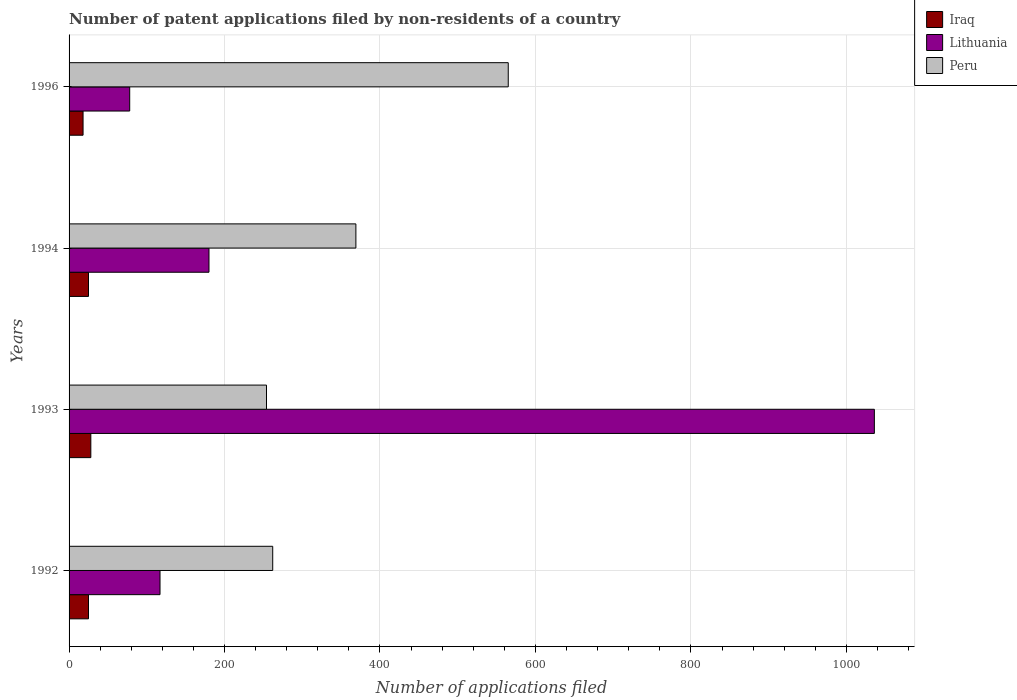How many different coloured bars are there?
Make the answer very short. 3. How many groups of bars are there?
Provide a succinct answer. 4. Are the number of bars per tick equal to the number of legend labels?
Ensure brevity in your answer.  Yes. How many bars are there on the 2nd tick from the bottom?
Your answer should be compact. 3. What is the label of the 4th group of bars from the top?
Ensure brevity in your answer.  1992. In how many cases, is the number of bars for a given year not equal to the number of legend labels?
Offer a terse response. 0. What is the number of applications filed in Lithuania in 1994?
Offer a very short reply. 180. Across all years, what is the maximum number of applications filed in Peru?
Your response must be concise. 565. In which year was the number of applications filed in Iraq maximum?
Give a very brief answer. 1993. What is the total number of applications filed in Peru in the graph?
Make the answer very short. 1450. What is the difference between the number of applications filed in Lithuania in 1993 and that in 1994?
Provide a succinct answer. 856. What is the difference between the number of applications filed in Iraq in 1994 and the number of applications filed in Peru in 1993?
Your answer should be very brief. -229. What is the average number of applications filed in Peru per year?
Keep it short and to the point. 362.5. In the year 1992, what is the difference between the number of applications filed in Peru and number of applications filed in Iraq?
Keep it short and to the point. 237. In how many years, is the number of applications filed in Peru greater than 120 ?
Your answer should be compact. 4. What is the ratio of the number of applications filed in Lithuania in 1993 to that in 1996?
Keep it short and to the point. 13.28. Is the number of applications filed in Peru in 1993 less than that in 1994?
Provide a short and direct response. Yes. Is the difference between the number of applications filed in Peru in 1994 and 1996 greater than the difference between the number of applications filed in Iraq in 1994 and 1996?
Ensure brevity in your answer.  No. What is the difference between the highest and the second highest number of applications filed in Peru?
Keep it short and to the point. 196. What is the difference between the highest and the lowest number of applications filed in Lithuania?
Provide a succinct answer. 958. Is the sum of the number of applications filed in Iraq in 1994 and 1996 greater than the maximum number of applications filed in Lithuania across all years?
Your answer should be compact. No. What does the 1st bar from the bottom in 1996 represents?
Offer a terse response. Iraq. Are all the bars in the graph horizontal?
Keep it short and to the point. Yes. How many years are there in the graph?
Your answer should be compact. 4. Are the values on the major ticks of X-axis written in scientific E-notation?
Offer a very short reply. No. Does the graph contain any zero values?
Keep it short and to the point. No. Does the graph contain grids?
Your answer should be very brief. Yes. Where does the legend appear in the graph?
Offer a very short reply. Top right. How many legend labels are there?
Your response must be concise. 3. How are the legend labels stacked?
Offer a very short reply. Vertical. What is the title of the graph?
Offer a very short reply. Number of patent applications filed by non-residents of a country. Does "Canada" appear as one of the legend labels in the graph?
Give a very brief answer. No. What is the label or title of the X-axis?
Your response must be concise. Number of applications filed. What is the label or title of the Y-axis?
Make the answer very short. Years. What is the Number of applications filed of Iraq in 1992?
Offer a very short reply. 25. What is the Number of applications filed in Lithuania in 1992?
Your answer should be very brief. 117. What is the Number of applications filed in Peru in 1992?
Provide a short and direct response. 262. What is the Number of applications filed of Iraq in 1993?
Offer a very short reply. 28. What is the Number of applications filed in Lithuania in 1993?
Offer a very short reply. 1036. What is the Number of applications filed in Peru in 1993?
Ensure brevity in your answer.  254. What is the Number of applications filed in Iraq in 1994?
Give a very brief answer. 25. What is the Number of applications filed of Lithuania in 1994?
Your answer should be very brief. 180. What is the Number of applications filed in Peru in 1994?
Your answer should be very brief. 369. What is the Number of applications filed in Iraq in 1996?
Offer a very short reply. 18. What is the Number of applications filed of Peru in 1996?
Your answer should be compact. 565. Across all years, what is the maximum Number of applications filed in Lithuania?
Your answer should be very brief. 1036. Across all years, what is the maximum Number of applications filed of Peru?
Make the answer very short. 565. Across all years, what is the minimum Number of applications filed in Iraq?
Your response must be concise. 18. Across all years, what is the minimum Number of applications filed in Lithuania?
Ensure brevity in your answer.  78. Across all years, what is the minimum Number of applications filed in Peru?
Give a very brief answer. 254. What is the total Number of applications filed in Iraq in the graph?
Offer a very short reply. 96. What is the total Number of applications filed in Lithuania in the graph?
Offer a terse response. 1411. What is the total Number of applications filed of Peru in the graph?
Ensure brevity in your answer.  1450. What is the difference between the Number of applications filed of Lithuania in 1992 and that in 1993?
Ensure brevity in your answer.  -919. What is the difference between the Number of applications filed of Iraq in 1992 and that in 1994?
Keep it short and to the point. 0. What is the difference between the Number of applications filed of Lithuania in 1992 and that in 1994?
Provide a succinct answer. -63. What is the difference between the Number of applications filed in Peru in 1992 and that in 1994?
Offer a terse response. -107. What is the difference between the Number of applications filed in Iraq in 1992 and that in 1996?
Provide a succinct answer. 7. What is the difference between the Number of applications filed of Lithuania in 1992 and that in 1996?
Your answer should be compact. 39. What is the difference between the Number of applications filed of Peru in 1992 and that in 1996?
Provide a succinct answer. -303. What is the difference between the Number of applications filed in Iraq in 1993 and that in 1994?
Provide a short and direct response. 3. What is the difference between the Number of applications filed of Lithuania in 1993 and that in 1994?
Provide a short and direct response. 856. What is the difference between the Number of applications filed in Peru in 1993 and that in 1994?
Your answer should be compact. -115. What is the difference between the Number of applications filed in Lithuania in 1993 and that in 1996?
Offer a very short reply. 958. What is the difference between the Number of applications filed of Peru in 1993 and that in 1996?
Offer a terse response. -311. What is the difference between the Number of applications filed of Iraq in 1994 and that in 1996?
Provide a succinct answer. 7. What is the difference between the Number of applications filed of Lithuania in 1994 and that in 1996?
Provide a succinct answer. 102. What is the difference between the Number of applications filed in Peru in 1994 and that in 1996?
Your response must be concise. -196. What is the difference between the Number of applications filed in Iraq in 1992 and the Number of applications filed in Lithuania in 1993?
Make the answer very short. -1011. What is the difference between the Number of applications filed in Iraq in 1992 and the Number of applications filed in Peru in 1993?
Ensure brevity in your answer.  -229. What is the difference between the Number of applications filed of Lithuania in 1992 and the Number of applications filed of Peru in 1993?
Ensure brevity in your answer.  -137. What is the difference between the Number of applications filed of Iraq in 1992 and the Number of applications filed of Lithuania in 1994?
Provide a succinct answer. -155. What is the difference between the Number of applications filed in Iraq in 1992 and the Number of applications filed in Peru in 1994?
Your answer should be compact. -344. What is the difference between the Number of applications filed in Lithuania in 1992 and the Number of applications filed in Peru in 1994?
Offer a terse response. -252. What is the difference between the Number of applications filed in Iraq in 1992 and the Number of applications filed in Lithuania in 1996?
Provide a short and direct response. -53. What is the difference between the Number of applications filed in Iraq in 1992 and the Number of applications filed in Peru in 1996?
Ensure brevity in your answer.  -540. What is the difference between the Number of applications filed of Lithuania in 1992 and the Number of applications filed of Peru in 1996?
Provide a succinct answer. -448. What is the difference between the Number of applications filed in Iraq in 1993 and the Number of applications filed in Lithuania in 1994?
Provide a short and direct response. -152. What is the difference between the Number of applications filed in Iraq in 1993 and the Number of applications filed in Peru in 1994?
Offer a very short reply. -341. What is the difference between the Number of applications filed of Lithuania in 1993 and the Number of applications filed of Peru in 1994?
Provide a succinct answer. 667. What is the difference between the Number of applications filed in Iraq in 1993 and the Number of applications filed in Lithuania in 1996?
Your answer should be very brief. -50. What is the difference between the Number of applications filed of Iraq in 1993 and the Number of applications filed of Peru in 1996?
Ensure brevity in your answer.  -537. What is the difference between the Number of applications filed of Lithuania in 1993 and the Number of applications filed of Peru in 1996?
Your answer should be very brief. 471. What is the difference between the Number of applications filed of Iraq in 1994 and the Number of applications filed of Lithuania in 1996?
Offer a very short reply. -53. What is the difference between the Number of applications filed in Iraq in 1994 and the Number of applications filed in Peru in 1996?
Your response must be concise. -540. What is the difference between the Number of applications filed in Lithuania in 1994 and the Number of applications filed in Peru in 1996?
Provide a short and direct response. -385. What is the average Number of applications filed of Lithuania per year?
Offer a terse response. 352.75. What is the average Number of applications filed in Peru per year?
Provide a succinct answer. 362.5. In the year 1992, what is the difference between the Number of applications filed of Iraq and Number of applications filed of Lithuania?
Keep it short and to the point. -92. In the year 1992, what is the difference between the Number of applications filed of Iraq and Number of applications filed of Peru?
Offer a very short reply. -237. In the year 1992, what is the difference between the Number of applications filed in Lithuania and Number of applications filed in Peru?
Your answer should be compact. -145. In the year 1993, what is the difference between the Number of applications filed in Iraq and Number of applications filed in Lithuania?
Your answer should be very brief. -1008. In the year 1993, what is the difference between the Number of applications filed in Iraq and Number of applications filed in Peru?
Your answer should be very brief. -226. In the year 1993, what is the difference between the Number of applications filed of Lithuania and Number of applications filed of Peru?
Provide a short and direct response. 782. In the year 1994, what is the difference between the Number of applications filed of Iraq and Number of applications filed of Lithuania?
Ensure brevity in your answer.  -155. In the year 1994, what is the difference between the Number of applications filed in Iraq and Number of applications filed in Peru?
Offer a terse response. -344. In the year 1994, what is the difference between the Number of applications filed in Lithuania and Number of applications filed in Peru?
Keep it short and to the point. -189. In the year 1996, what is the difference between the Number of applications filed of Iraq and Number of applications filed of Lithuania?
Give a very brief answer. -60. In the year 1996, what is the difference between the Number of applications filed of Iraq and Number of applications filed of Peru?
Make the answer very short. -547. In the year 1996, what is the difference between the Number of applications filed in Lithuania and Number of applications filed in Peru?
Your answer should be very brief. -487. What is the ratio of the Number of applications filed of Iraq in 1992 to that in 1993?
Make the answer very short. 0.89. What is the ratio of the Number of applications filed in Lithuania in 1992 to that in 1993?
Your response must be concise. 0.11. What is the ratio of the Number of applications filed of Peru in 1992 to that in 1993?
Make the answer very short. 1.03. What is the ratio of the Number of applications filed in Lithuania in 1992 to that in 1994?
Offer a very short reply. 0.65. What is the ratio of the Number of applications filed of Peru in 1992 to that in 1994?
Offer a very short reply. 0.71. What is the ratio of the Number of applications filed in Iraq in 1992 to that in 1996?
Keep it short and to the point. 1.39. What is the ratio of the Number of applications filed of Lithuania in 1992 to that in 1996?
Your response must be concise. 1.5. What is the ratio of the Number of applications filed in Peru in 1992 to that in 1996?
Offer a very short reply. 0.46. What is the ratio of the Number of applications filed in Iraq in 1993 to that in 1994?
Your answer should be very brief. 1.12. What is the ratio of the Number of applications filed in Lithuania in 1993 to that in 1994?
Provide a short and direct response. 5.76. What is the ratio of the Number of applications filed of Peru in 1993 to that in 1994?
Your response must be concise. 0.69. What is the ratio of the Number of applications filed of Iraq in 1993 to that in 1996?
Make the answer very short. 1.56. What is the ratio of the Number of applications filed of Lithuania in 1993 to that in 1996?
Ensure brevity in your answer.  13.28. What is the ratio of the Number of applications filed of Peru in 1993 to that in 1996?
Provide a short and direct response. 0.45. What is the ratio of the Number of applications filed of Iraq in 1994 to that in 1996?
Ensure brevity in your answer.  1.39. What is the ratio of the Number of applications filed of Lithuania in 1994 to that in 1996?
Offer a terse response. 2.31. What is the ratio of the Number of applications filed in Peru in 1994 to that in 1996?
Provide a succinct answer. 0.65. What is the difference between the highest and the second highest Number of applications filed in Lithuania?
Make the answer very short. 856. What is the difference between the highest and the second highest Number of applications filed in Peru?
Offer a terse response. 196. What is the difference between the highest and the lowest Number of applications filed in Iraq?
Your answer should be very brief. 10. What is the difference between the highest and the lowest Number of applications filed in Lithuania?
Provide a succinct answer. 958. What is the difference between the highest and the lowest Number of applications filed of Peru?
Give a very brief answer. 311. 